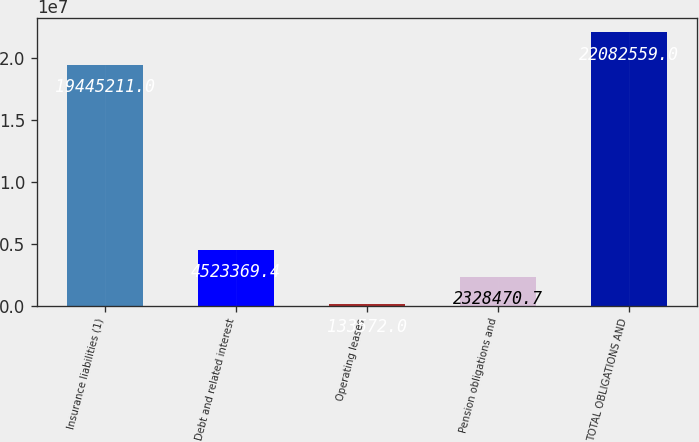<chart> <loc_0><loc_0><loc_500><loc_500><bar_chart><fcel>Insurance liabilities (1)<fcel>Debt and related interest<fcel>Operating leases<fcel>Pension obligations and<fcel>TOTAL OBLIGATIONS AND<nl><fcel>1.94452e+07<fcel>4.52337e+06<fcel>133572<fcel>2.32847e+06<fcel>2.20826e+07<nl></chart> 